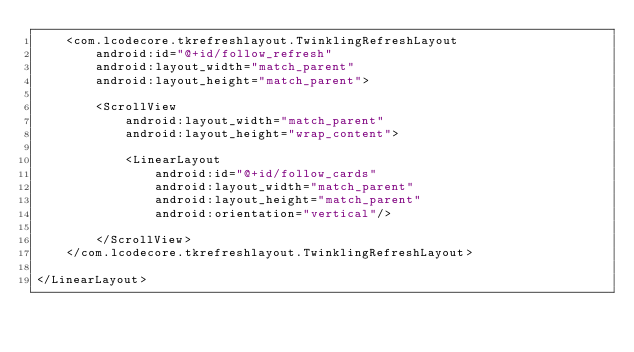Convert code to text. <code><loc_0><loc_0><loc_500><loc_500><_XML_>    <com.lcodecore.tkrefreshlayout.TwinklingRefreshLayout
        android:id="@+id/follow_refresh"
        android:layout_width="match_parent"
        android:layout_height="match_parent">

        <ScrollView
            android:layout_width="match_parent"
            android:layout_height="wrap_content">

            <LinearLayout
                android:id="@+id/follow_cards"
                android:layout_width="match_parent"
                android:layout_height="match_parent"
                android:orientation="vertical"/>

        </ScrollView>
    </com.lcodecore.tkrefreshlayout.TwinklingRefreshLayout>

</LinearLayout></code> 